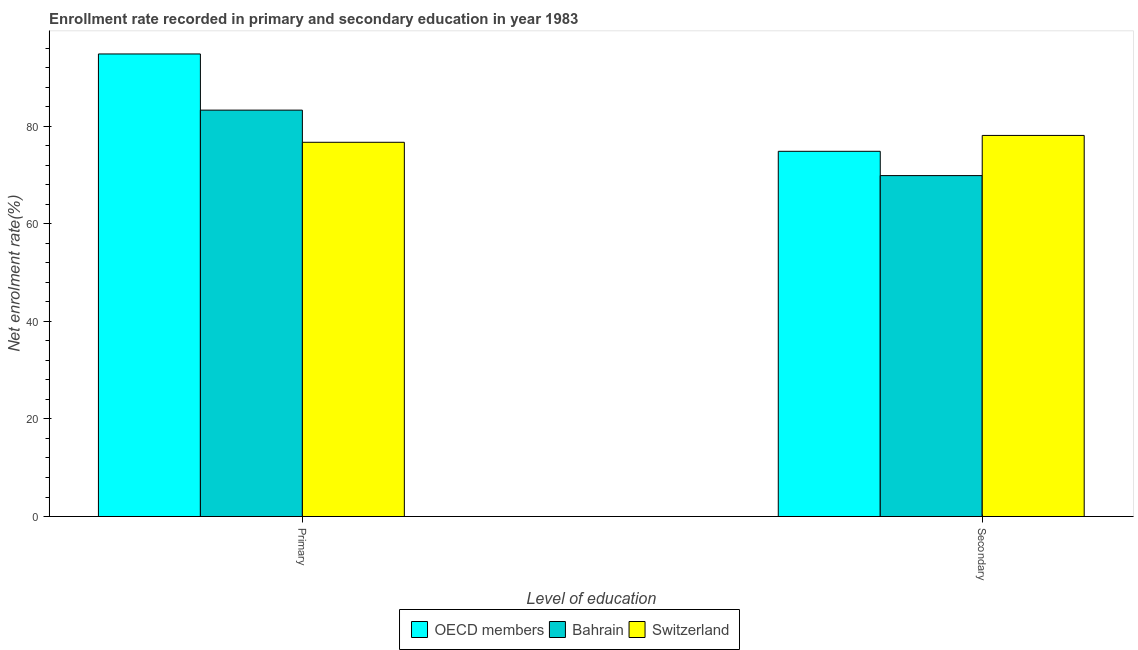What is the label of the 2nd group of bars from the left?
Provide a succinct answer. Secondary. What is the enrollment rate in secondary education in Bahrain?
Your answer should be very brief. 69.9. Across all countries, what is the maximum enrollment rate in secondary education?
Offer a terse response. 78.14. Across all countries, what is the minimum enrollment rate in secondary education?
Your answer should be very brief. 69.9. In which country was the enrollment rate in secondary education maximum?
Your response must be concise. Switzerland. In which country was the enrollment rate in primary education minimum?
Your answer should be compact. Switzerland. What is the total enrollment rate in primary education in the graph?
Provide a succinct answer. 254.9. What is the difference between the enrollment rate in secondary education in Bahrain and that in OECD members?
Keep it short and to the point. -4.98. What is the difference between the enrollment rate in secondary education in OECD members and the enrollment rate in primary education in Bahrain?
Provide a succinct answer. -8.44. What is the average enrollment rate in primary education per country?
Offer a terse response. 84.97. What is the difference between the enrollment rate in primary education and enrollment rate in secondary education in Bahrain?
Offer a very short reply. 13.42. In how many countries, is the enrollment rate in primary education greater than 36 %?
Your answer should be very brief. 3. What is the ratio of the enrollment rate in primary education in OECD members to that in Bahrain?
Your answer should be compact. 1.14. What does the 1st bar from the left in Primary represents?
Your answer should be very brief. OECD members. What does the 2nd bar from the right in Primary represents?
Provide a short and direct response. Bahrain. How many bars are there?
Your answer should be very brief. 6. How many countries are there in the graph?
Provide a short and direct response. 3. Does the graph contain any zero values?
Provide a short and direct response. No. Does the graph contain grids?
Your answer should be very brief. No. Where does the legend appear in the graph?
Give a very brief answer. Bottom center. How many legend labels are there?
Give a very brief answer. 3. How are the legend labels stacked?
Keep it short and to the point. Horizontal. What is the title of the graph?
Ensure brevity in your answer.  Enrollment rate recorded in primary and secondary education in year 1983. What is the label or title of the X-axis?
Your answer should be very brief. Level of education. What is the label or title of the Y-axis?
Give a very brief answer. Net enrolment rate(%). What is the Net enrolment rate(%) in OECD members in Primary?
Provide a succinct answer. 94.84. What is the Net enrolment rate(%) in Bahrain in Primary?
Offer a terse response. 83.32. What is the Net enrolment rate(%) of Switzerland in Primary?
Provide a short and direct response. 76.73. What is the Net enrolment rate(%) in OECD members in Secondary?
Make the answer very short. 74.88. What is the Net enrolment rate(%) of Bahrain in Secondary?
Offer a terse response. 69.9. What is the Net enrolment rate(%) of Switzerland in Secondary?
Give a very brief answer. 78.14. Across all Level of education, what is the maximum Net enrolment rate(%) in OECD members?
Your answer should be very brief. 94.84. Across all Level of education, what is the maximum Net enrolment rate(%) in Bahrain?
Your response must be concise. 83.32. Across all Level of education, what is the maximum Net enrolment rate(%) in Switzerland?
Give a very brief answer. 78.14. Across all Level of education, what is the minimum Net enrolment rate(%) of OECD members?
Keep it short and to the point. 74.88. Across all Level of education, what is the minimum Net enrolment rate(%) of Bahrain?
Ensure brevity in your answer.  69.9. Across all Level of education, what is the minimum Net enrolment rate(%) of Switzerland?
Keep it short and to the point. 76.73. What is the total Net enrolment rate(%) of OECD members in the graph?
Your response must be concise. 169.73. What is the total Net enrolment rate(%) of Bahrain in the graph?
Provide a succinct answer. 153.23. What is the total Net enrolment rate(%) of Switzerland in the graph?
Offer a terse response. 154.87. What is the difference between the Net enrolment rate(%) in OECD members in Primary and that in Secondary?
Your answer should be very brief. 19.96. What is the difference between the Net enrolment rate(%) of Bahrain in Primary and that in Secondary?
Offer a very short reply. 13.42. What is the difference between the Net enrolment rate(%) of Switzerland in Primary and that in Secondary?
Provide a short and direct response. -1.41. What is the difference between the Net enrolment rate(%) of OECD members in Primary and the Net enrolment rate(%) of Bahrain in Secondary?
Offer a terse response. 24.94. What is the difference between the Net enrolment rate(%) in OECD members in Primary and the Net enrolment rate(%) in Switzerland in Secondary?
Your response must be concise. 16.7. What is the difference between the Net enrolment rate(%) in Bahrain in Primary and the Net enrolment rate(%) in Switzerland in Secondary?
Keep it short and to the point. 5.19. What is the average Net enrolment rate(%) of OECD members per Level of education?
Give a very brief answer. 84.86. What is the average Net enrolment rate(%) in Bahrain per Level of education?
Offer a very short reply. 76.61. What is the average Net enrolment rate(%) in Switzerland per Level of education?
Keep it short and to the point. 77.44. What is the difference between the Net enrolment rate(%) of OECD members and Net enrolment rate(%) of Bahrain in Primary?
Ensure brevity in your answer.  11.52. What is the difference between the Net enrolment rate(%) of OECD members and Net enrolment rate(%) of Switzerland in Primary?
Give a very brief answer. 18.11. What is the difference between the Net enrolment rate(%) in Bahrain and Net enrolment rate(%) in Switzerland in Primary?
Offer a terse response. 6.59. What is the difference between the Net enrolment rate(%) in OECD members and Net enrolment rate(%) in Bahrain in Secondary?
Ensure brevity in your answer.  4.98. What is the difference between the Net enrolment rate(%) of OECD members and Net enrolment rate(%) of Switzerland in Secondary?
Provide a short and direct response. -3.26. What is the difference between the Net enrolment rate(%) of Bahrain and Net enrolment rate(%) of Switzerland in Secondary?
Offer a very short reply. -8.24. What is the ratio of the Net enrolment rate(%) in OECD members in Primary to that in Secondary?
Make the answer very short. 1.27. What is the ratio of the Net enrolment rate(%) in Bahrain in Primary to that in Secondary?
Ensure brevity in your answer.  1.19. What is the difference between the highest and the second highest Net enrolment rate(%) in OECD members?
Offer a terse response. 19.96. What is the difference between the highest and the second highest Net enrolment rate(%) of Bahrain?
Make the answer very short. 13.42. What is the difference between the highest and the second highest Net enrolment rate(%) in Switzerland?
Your answer should be very brief. 1.41. What is the difference between the highest and the lowest Net enrolment rate(%) in OECD members?
Your answer should be very brief. 19.96. What is the difference between the highest and the lowest Net enrolment rate(%) of Bahrain?
Make the answer very short. 13.42. What is the difference between the highest and the lowest Net enrolment rate(%) in Switzerland?
Your answer should be very brief. 1.41. 